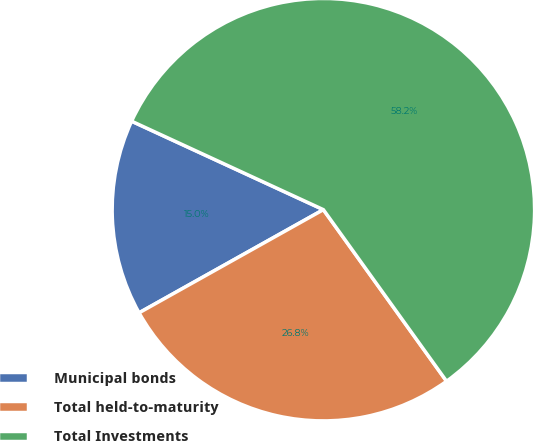Convert chart to OTSL. <chart><loc_0><loc_0><loc_500><loc_500><pie_chart><fcel>Municipal bonds<fcel>Total held-to-maturity<fcel>Total Investments<nl><fcel>15.0%<fcel>26.79%<fcel>58.21%<nl></chart> 